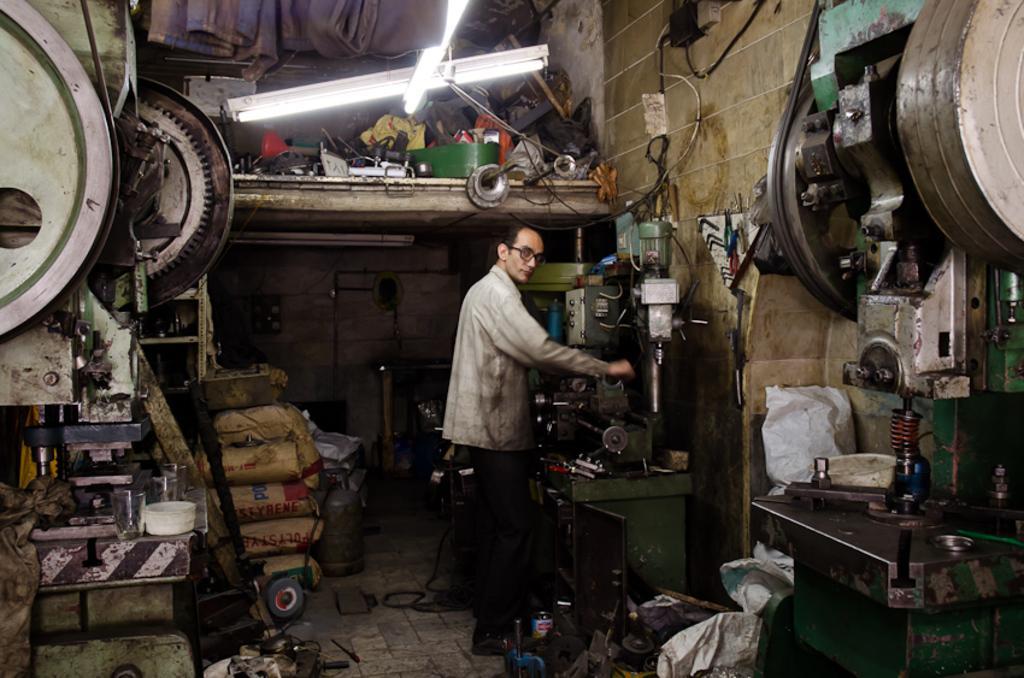Can you describe this image briefly? In this picture there is a man standing and holding the object and there are machines and there are objects. At the back there are bags and there are objects. At the top there are objects in the shelf and there are lights. At the bottom there are objects and there is a wire on the floor. 